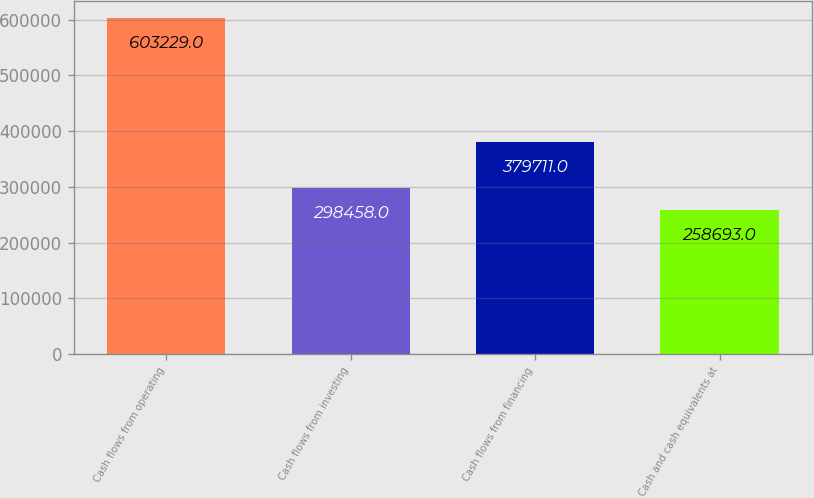Convert chart to OTSL. <chart><loc_0><loc_0><loc_500><loc_500><bar_chart><fcel>Cash flows from operating<fcel>Cash flows from investing<fcel>Cash flows from financing<fcel>Cash and cash equivalents at<nl><fcel>603229<fcel>298458<fcel>379711<fcel>258693<nl></chart> 